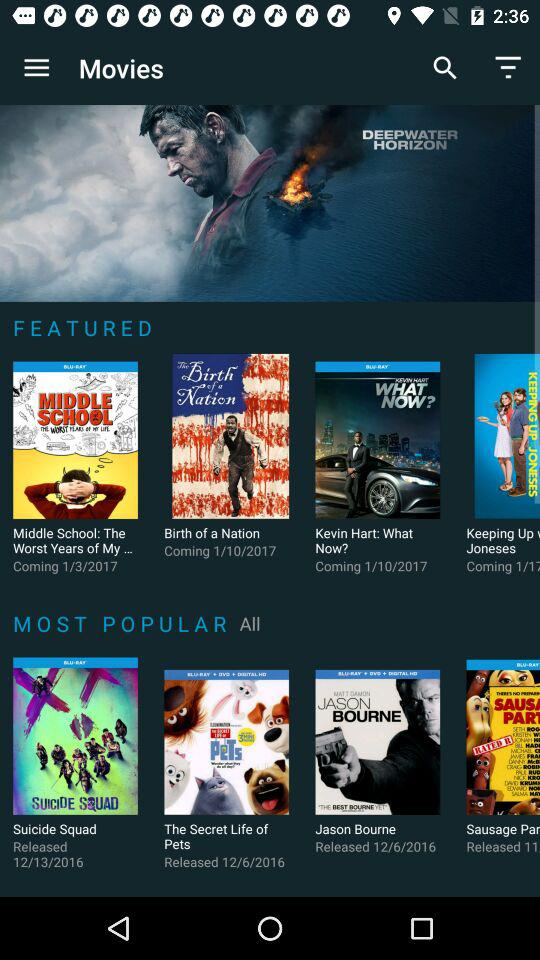What is the release date for the movie "Birth of a Nation"? The release date for the movie "Birth of a Nation" is October 1, 2017. 